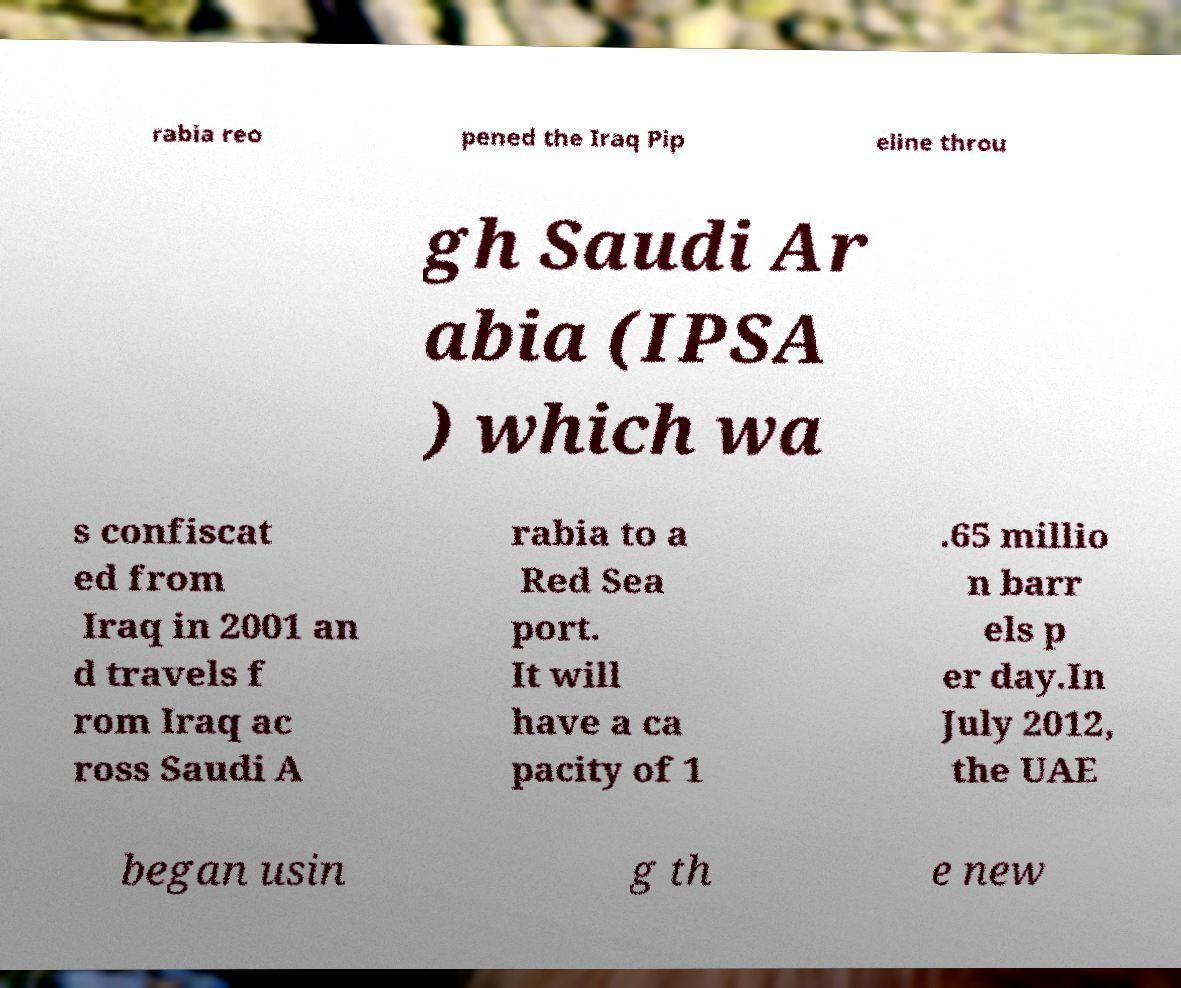For documentation purposes, I need the text within this image transcribed. Could you provide that? rabia reo pened the Iraq Pip eline throu gh Saudi Ar abia (IPSA ) which wa s confiscat ed from Iraq in 2001 an d travels f rom Iraq ac ross Saudi A rabia to a Red Sea port. It will have a ca pacity of 1 .65 millio n barr els p er day.In July 2012, the UAE began usin g th e new 